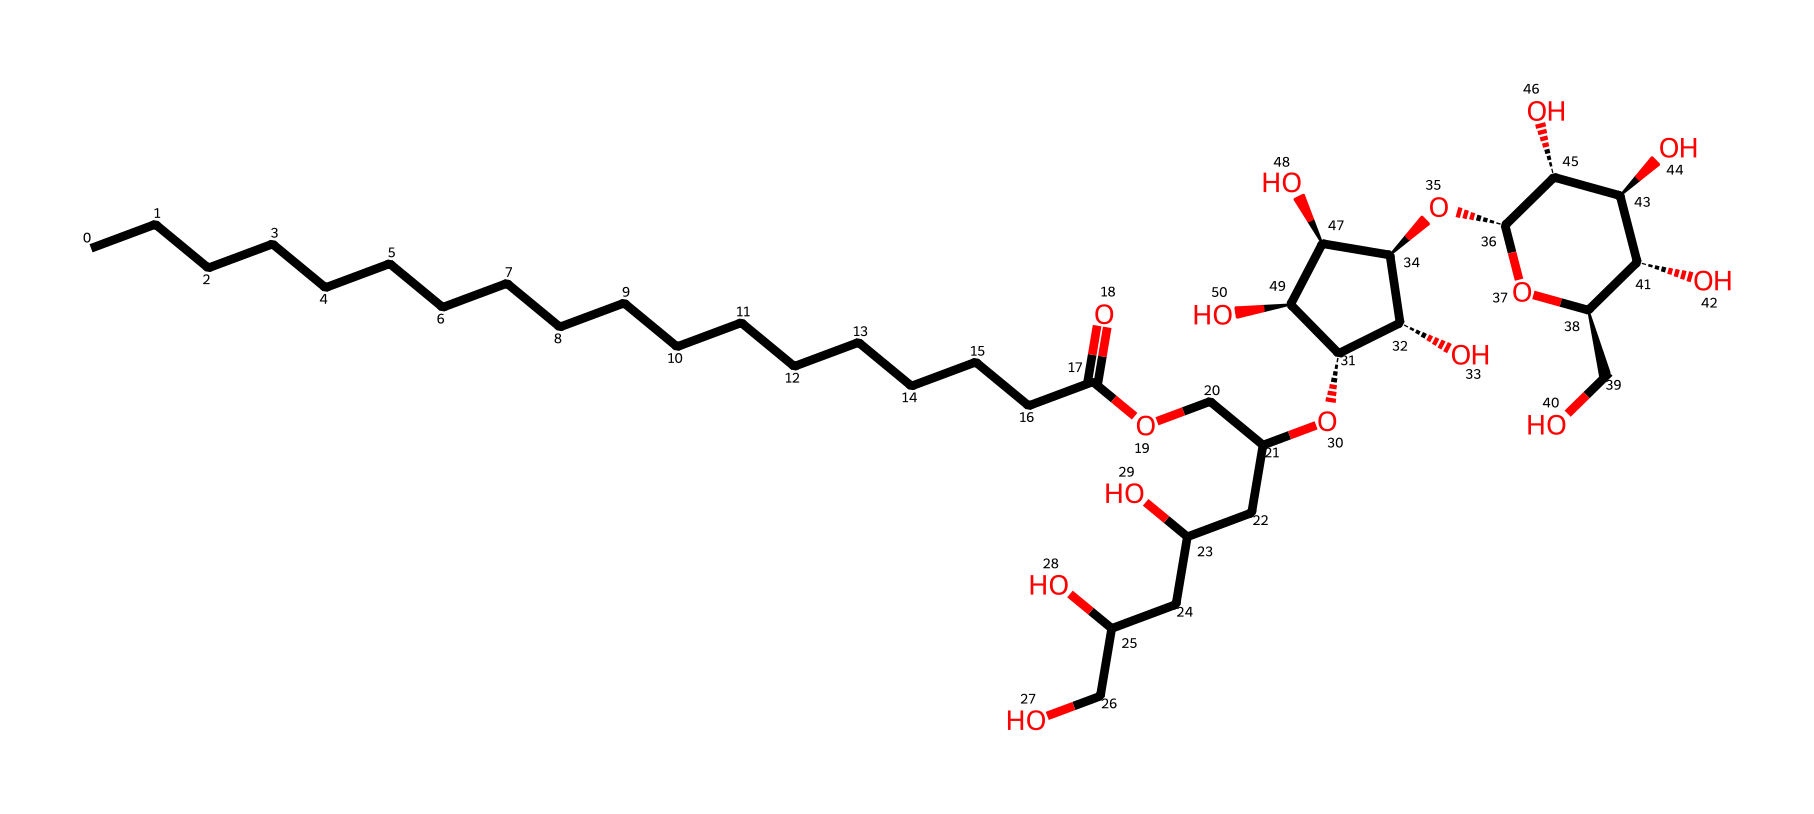What is the name of this chemical? The provided SMILES corresponds to polysorbate 20, which is a surfactant commonly used in food additives.
Answer: polysorbate 20 How many carbon atoms are in the structure? By analyzing the SMILES, we can count the number of "C" present; there are 20 carbon atoms listed in the linear chain and branched parts of the chemical structure.
Answer: 20 How many hydroxyl (OH) groups are present in this chemical? The presence of hydroxyl groups can be inferred from the "O" appearing in the structure attached to hydrogen atoms. There are 5 hydroxyl groups counted.
Answer: 5 What is the functional group indicated by the "OCC" segment in the SMILES? The segment "OCC" denotes an ether functional group due to the presence of oxygen bonded to two carbon atoms in the chain structure.
Answer: ether Is this chemical amphiphilic? The chemical has both hydrophilic parts (due to hydroxyl groups) and hydrophobic parts (the long carbon chain), which is indicative of an amphiphilic nature.
Answer: yes What is the typical application of polysorbate 20? Polysorbate 20 is widely used as an emulsifier in food products to stabilize mixtures of oil and water.
Answer: emulsifier Which portion of the chemical structure provides the surfactant properties? The long hydrocarbon chain (C18) of the structure provides hydrophobic characteristics, while the hydroxyl groups offer hydrophilic characteristics, which together contribute to its surfactant properties.
Answer: long hydrocarbon chain 